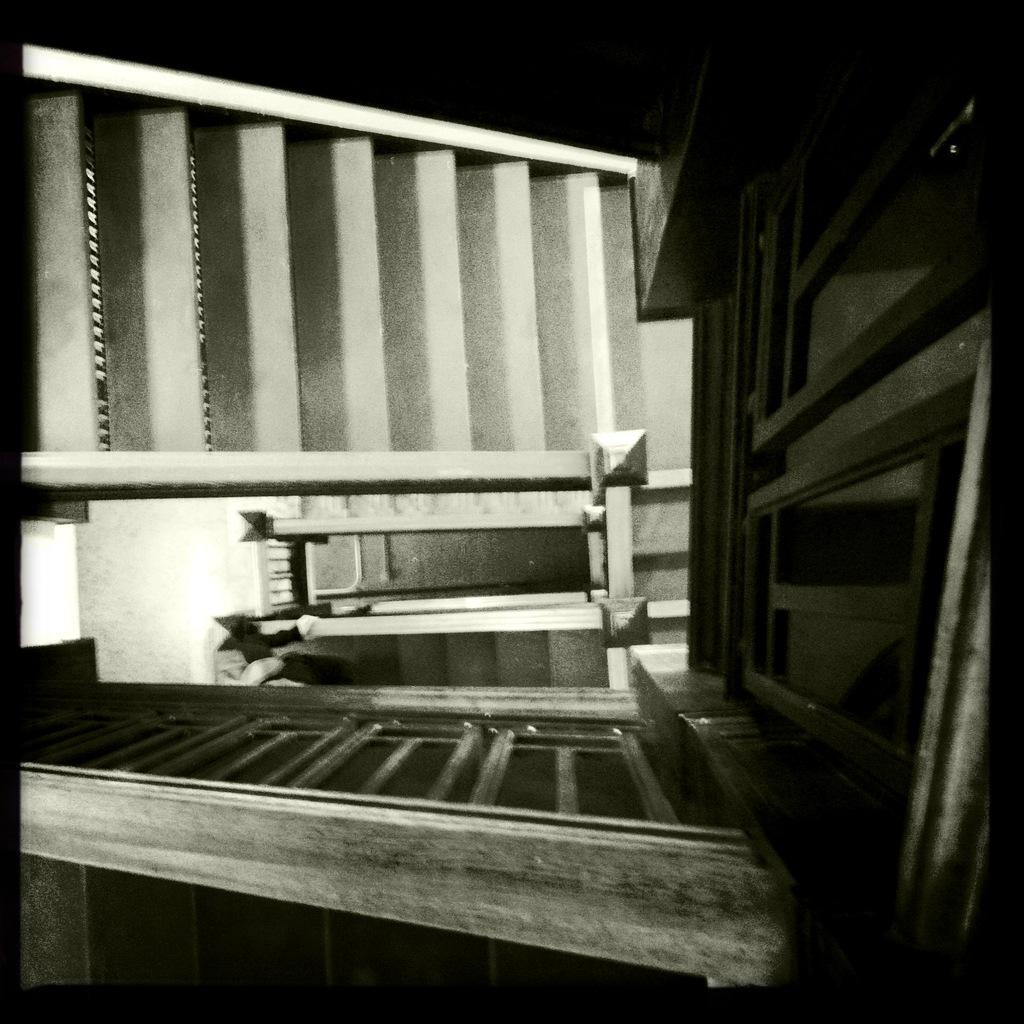What type of image is being described? The image appears to be an edited photo. What structures can be seen in the image? There are buildings, walls, and a bridge in the image. What type of waves can be seen crashing against the bridge in the image? There are no waves present in the image; it features a bridge without any water or crashing waves. What advice is being given in the image? There is no advice being given in the image; it is a still photo of buildings, walls, and a bridge. 